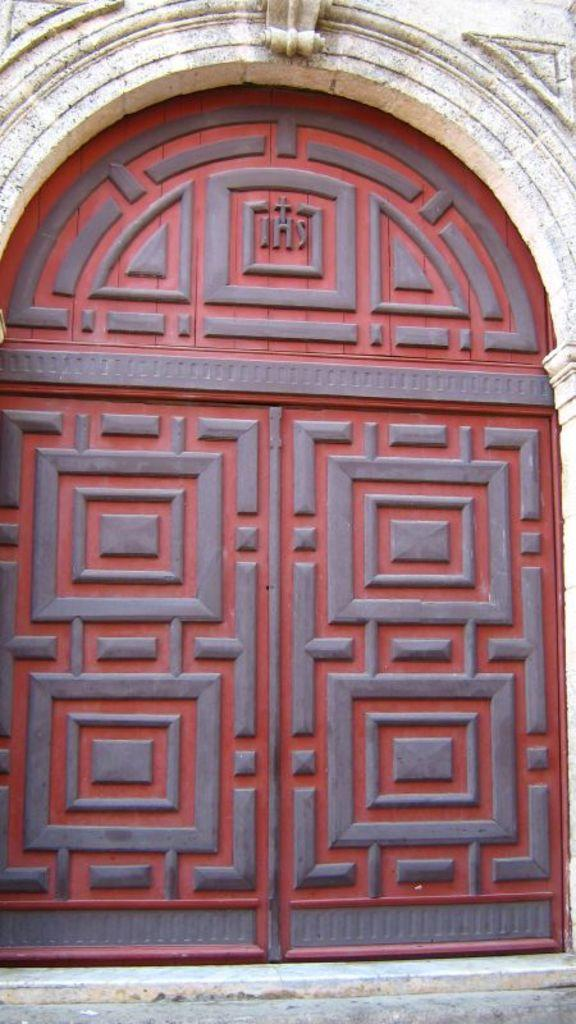What type of architectural feature can be seen in the image? There are doors in the image. What else can be seen in the image besides the doors? There is a wall in the image. What type of education is being taught in the image? There is no indication of education in the image; it only features doors and a wall. What design elements can be seen in the image? The image does not provide enough information to determine specific design elements. 